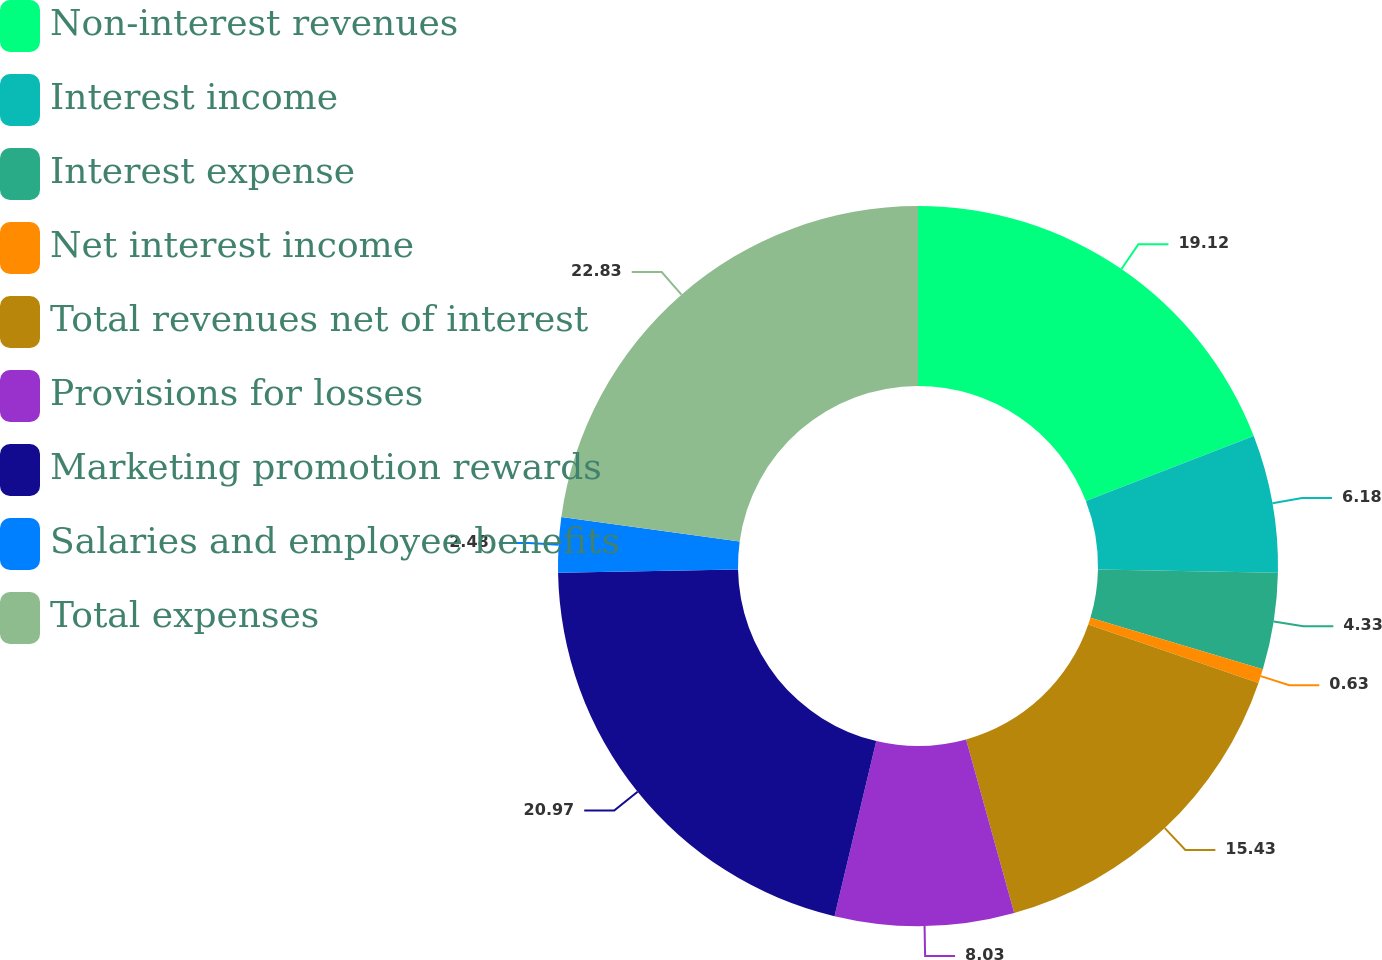<chart> <loc_0><loc_0><loc_500><loc_500><pie_chart><fcel>Non-interest revenues<fcel>Interest income<fcel>Interest expense<fcel>Net interest income<fcel>Total revenues net of interest<fcel>Provisions for losses<fcel>Marketing promotion rewards<fcel>Salaries and employee benefits<fcel>Total expenses<nl><fcel>19.12%<fcel>6.18%<fcel>4.33%<fcel>0.63%<fcel>15.43%<fcel>8.03%<fcel>20.97%<fcel>2.48%<fcel>22.82%<nl></chart> 